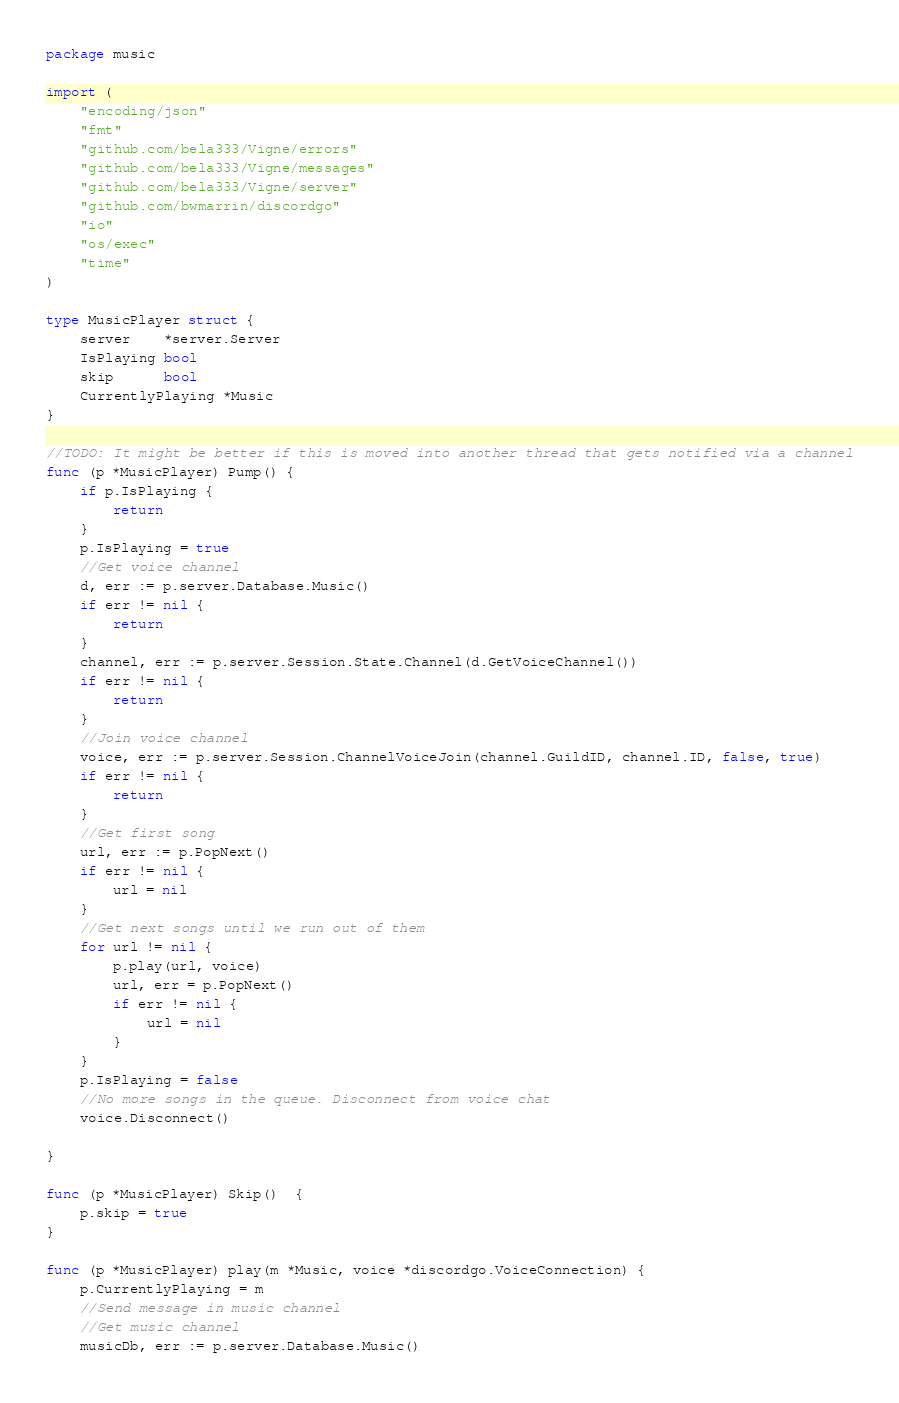<code> <loc_0><loc_0><loc_500><loc_500><_Go_>package music

import (
	"encoding/json"
	"fmt"
	"github.com/bela333/Vigne/errors"
	"github.com/bela333/Vigne/messages"
	"github.com/bela333/Vigne/server"
	"github.com/bwmarrin/discordgo"
	"io"
	"os/exec"
	"time"
)

type MusicPlayer struct {
	server    *server.Server
	IsPlaying bool
	skip      bool
	CurrentlyPlaying *Music
}

//TODO: It might be better if this is moved into another thread that gets notified via a channel
func (p *MusicPlayer) Pump() {
	if p.IsPlaying {
		return
	}
	p.IsPlaying = true
	//Get voice channel
	d, err := p.server.Database.Music()
	if err != nil {
		return
	}
	channel, err := p.server.Session.State.Channel(d.GetVoiceChannel())
	if err != nil {
		return
	}
	//Join voice channel
	voice, err := p.server.Session.ChannelVoiceJoin(channel.GuildID, channel.ID, false, true)
	if err != nil {
		return
	}
	//Get first song
	url, err := p.PopNext()
	if err != nil {
		url = nil
	}
	//Get next songs until we run out of them
	for url != nil {
		p.play(url, voice)
		url, err = p.PopNext()
		if err != nil {
			url = nil
		}
	}
	p.IsPlaying = false
	//No more songs in the queue. Disconnect from voice chat
	voice.Disconnect()

}

func (p *MusicPlayer) Skip()  {
	p.skip = true
}

func (p *MusicPlayer) play(m *Music, voice *discordgo.VoiceConnection) {
	p.CurrentlyPlaying = m
	//Send message in music channel
	//Get music channel
	musicDb, err := p.server.Database.Music()</code> 